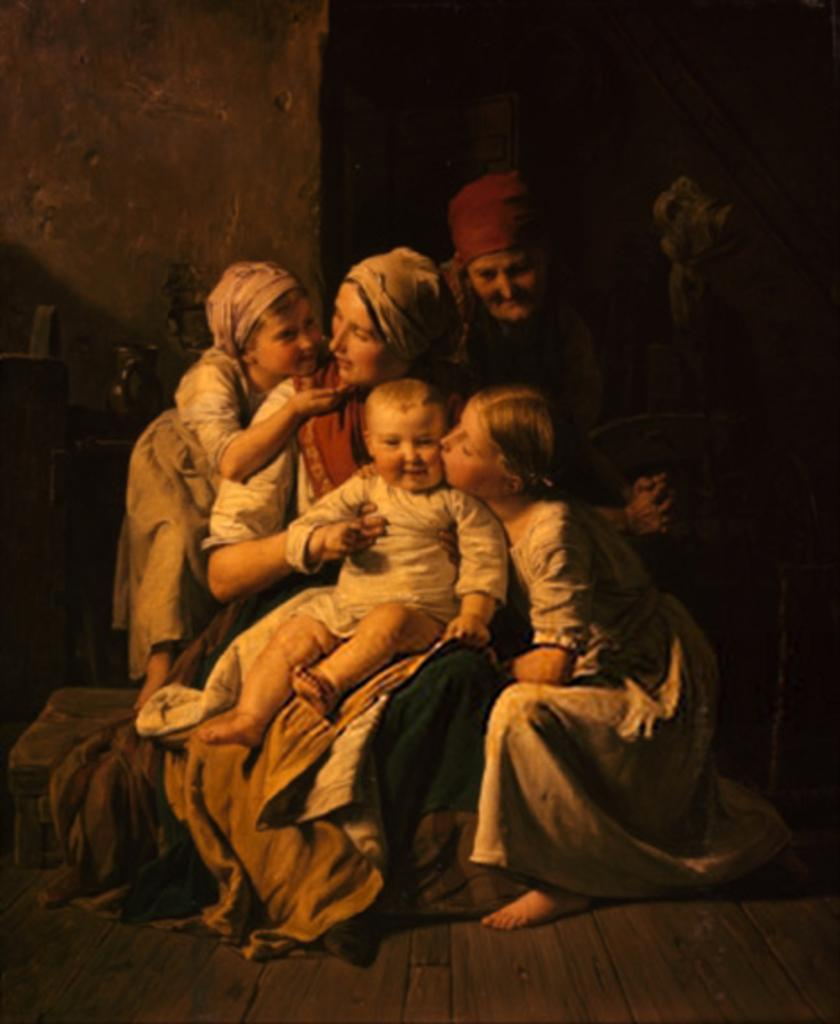How many people are present in the image? There are five people in the image, including three women and two kids. Can you describe the age range of the individuals in the image? The image features three adult women and two children. What type of building can be seen in the background of the image? There is no building visible in the image; it only features three women and two kids. 